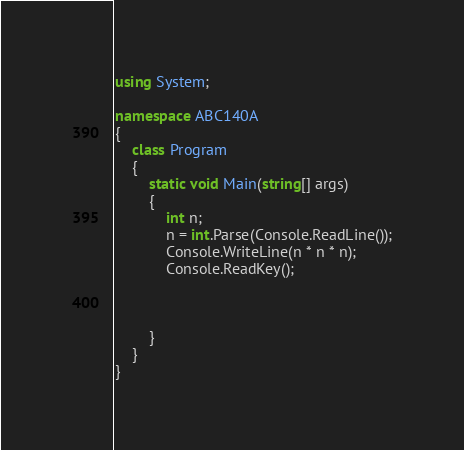Convert code to text. <code><loc_0><loc_0><loc_500><loc_500><_C#_>using System;

namespace ABC140A
{
    class Program
    {
        static void Main(string[] args)
        {
            int n;
            n = int.Parse(Console.ReadLine());
            Console.WriteLine(n * n * n);
            Console.ReadKey();


            
        }
    }
}
</code> 